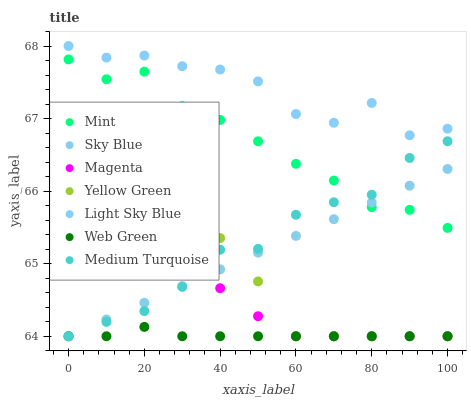Does Web Green have the minimum area under the curve?
Answer yes or no. Yes. Does Light Sky Blue have the maximum area under the curve?
Answer yes or no. Yes. Does Light Sky Blue have the minimum area under the curve?
Answer yes or no. No. Does Web Green have the maximum area under the curve?
Answer yes or no. No. Is Sky Blue the smoothest?
Answer yes or no. Yes. Is Light Sky Blue the roughest?
Answer yes or no. Yes. Is Web Green the smoothest?
Answer yes or no. No. Is Web Green the roughest?
Answer yes or no. No. Does Yellow Green have the lowest value?
Answer yes or no. Yes. Does Light Sky Blue have the lowest value?
Answer yes or no. No. Does Light Sky Blue have the highest value?
Answer yes or no. Yes. Does Web Green have the highest value?
Answer yes or no. No. Is Magenta less than Mint?
Answer yes or no. Yes. Is Light Sky Blue greater than Mint?
Answer yes or no. Yes. Does Sky Blue intersect Medium Turquoise?
Answer yes or no. Yes. Is Sky Blue less than Medium Turquoise?
Answer yes or no. No. Is Sky Blue greater than Medium Turquoise?
Answer yes or no. No. Does Magenta intersect Mint?
Answer yes or no. No. 